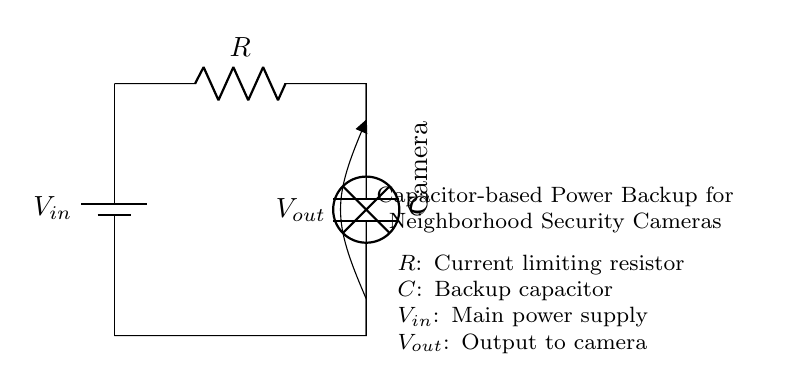What is the type of power supply used in this circuit? The circuit uses a battery as the power supply, indicated by the battery symbol labeled with V in.
Answer: battery What component limits the current in the circuit? The current limiting component is the resistor, denoted by the "R" label in the diagram.
Answer: resistor What is the purpose of the capacitor in this circuit? The capacitor serves as a backup power source, providing energy to the security camera in the absence of the main power supply.
Answer: backup power What is the output voltage of this circuit? The output voltage is represented by V out, which is taken from the connection across the capacitor and resistor.
Answer: V out What component is connected to the output of this circuit? A security camera is connected to the output, as indicated by the lamp symbol labeled with "Camera".
Answer: Camera Explain how the capacitor provides power to the camera when the main supply is off. When the main power supply is disconnected or fails, the capacitor discharges its stored energy to the camera. The resistor controls the discharge rate to ensure the camera receives power without drawing too much current quickly, sustaining operation temporarily until power is restored.
Answer: Capacitor discharges to power the camera 